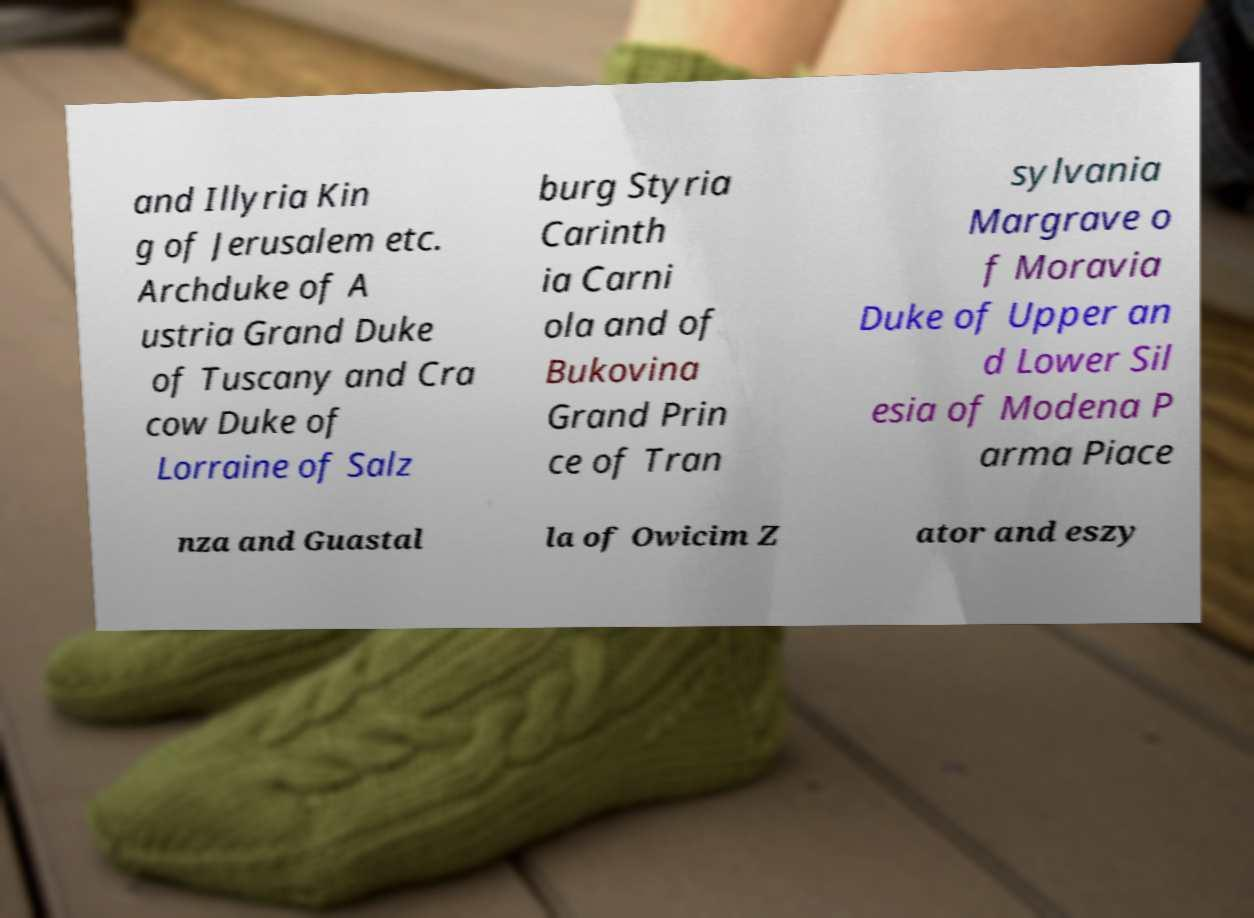What messages or text are displayed in this image? I need them in a readable, typed format. and Illyria Kin g of Jerusalem etc. Archduke of A ustria Grand Duke of Tuscany and Cra cow Duke of Lorraine of Salz burg Styria Carinth ia Carni ola and of Bukovina Grand Prin ce of Tran sylvania Margrave o f Moravia Duke of Upper an d Lower Sil esia of Modena P arma Piace nza and Guastal la of Owicim Z ator and eszy 